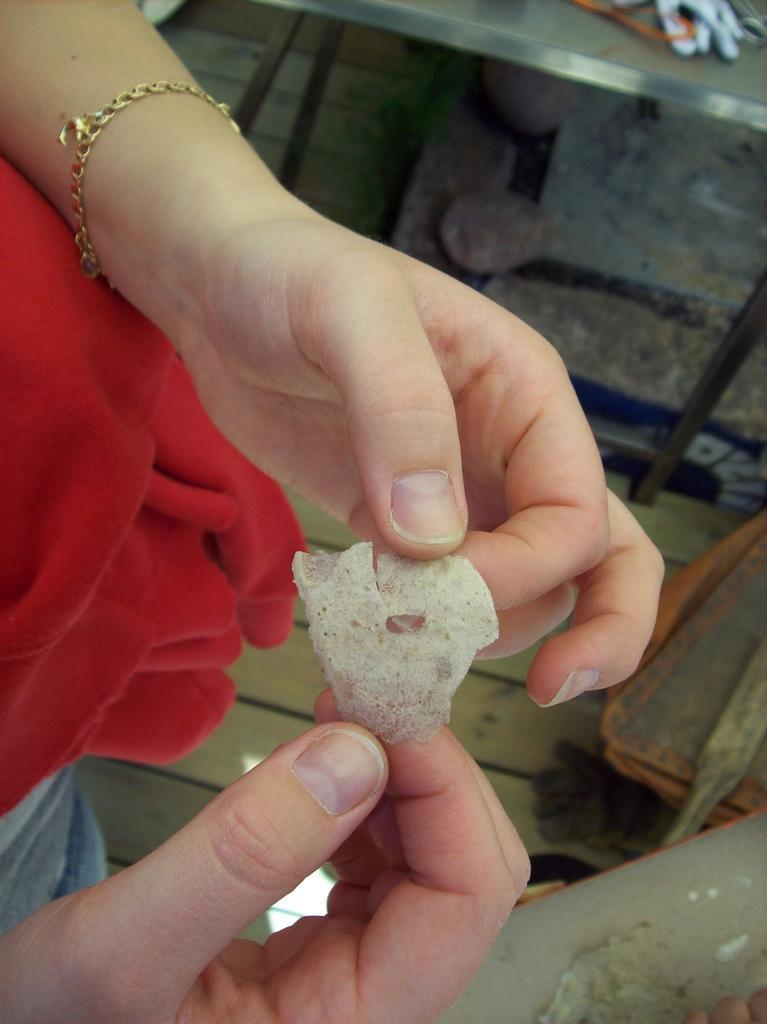What can be seen in the image? There is a person in the image. What is the person doing in the image? The person is holding an item with both hands. What type of flooring is visible in the image? There is a wooden floor visible in the image. How many tables can be seen in the image? There are two tables in the image. What religion is the person practicing in the image? There is no indication of any religious practice in the image. How many drains are visible in the image? There are no drains present in the image. 